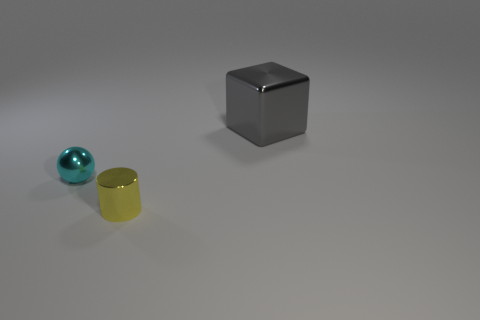There is a tiny cyan metallic object; does it have the same shape as the thing to the right of the small yellow cylinder?
Offer a very short reply. No. There is a metal thing that is left of the metal thing that is in front of the sphere; what number of cyan metal spheres are left of it?
Provide a succinct answer. 0. There is another shiny object that is the same size as the yellow thing; what is its color?
Your answer should be compact. Cyan. What is the size of the gray object behind the small thing to the left of the tiny shiny cylinder?
Your answer should be very brief. Large. How many other objects are there of the same size as the gray metal cube?
Keep it short and to the point. 0. What number of metallic balls are there?
Your answer should be compact. 1. Does the cyan metal thing have the same size as the gray metallic block?
Ensure brevity in your answer.  No. What number of other objects are there of the same shape as the small yellow metallic thing?
Provide a succinct answer. 0. What is the small object that is in front of the small object behind the tiny yellow metallic cylinder made of?
Keep it short and to the point. Metal. Are there any small yellow things behind the small yellow object?
Offer a terse response. No. 